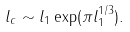<formula> <loc_0><loc_0><loc_500><loc_500>l _ { c } \sim l _ { 1 } \exp ( \pi l _ { 1 } ^ { 1 / 3 } ) .</formula> 